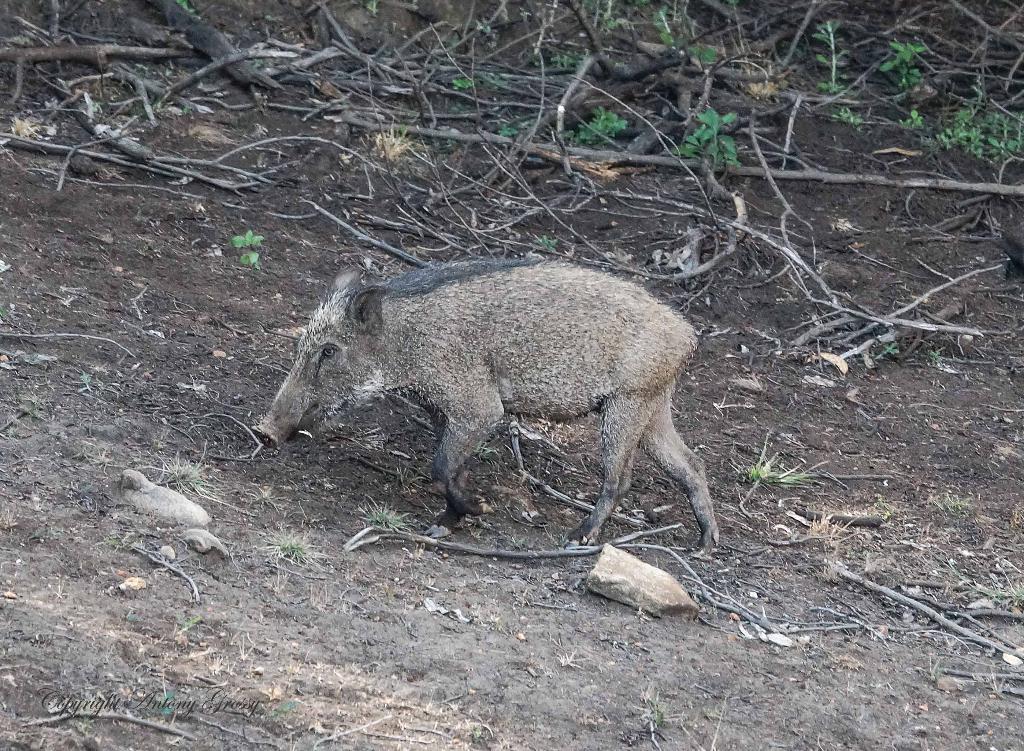In one or two sentences, can you explain what this image depicts? In this picture, we see an animal which looks like a pig. At the bottom, we see the soil, stones, grass and twigs. In the background, we see the twigs, herbs and the wooden sticks. 